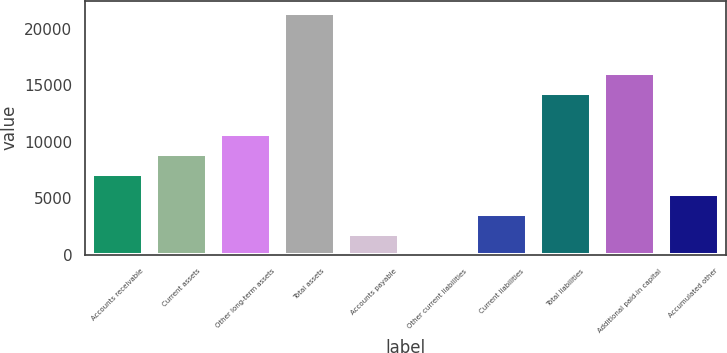Convert chart. <chart><loc_0><loc_0><loc_500><loc_500><bar_chart><fcel>Accounts receivable<fcel>Current assets<fcel>Other long-term assets<fcel>Total assets<fcel>Accounts payable<fcel>Other current liabilities<fcel>Current liabilities<fcel>Total liabilities<fcel>Additional paid-in capital<fcel>Accumulated other<nl><fcel>7165.6<fcel>8943<fcel>10720.4<fcel>21384.8<fcel>1833.4<fcel>56<fcel>3610.8<fcel>14275.2<fcel>16052.6<fcel>5388.2<nl></chart> 